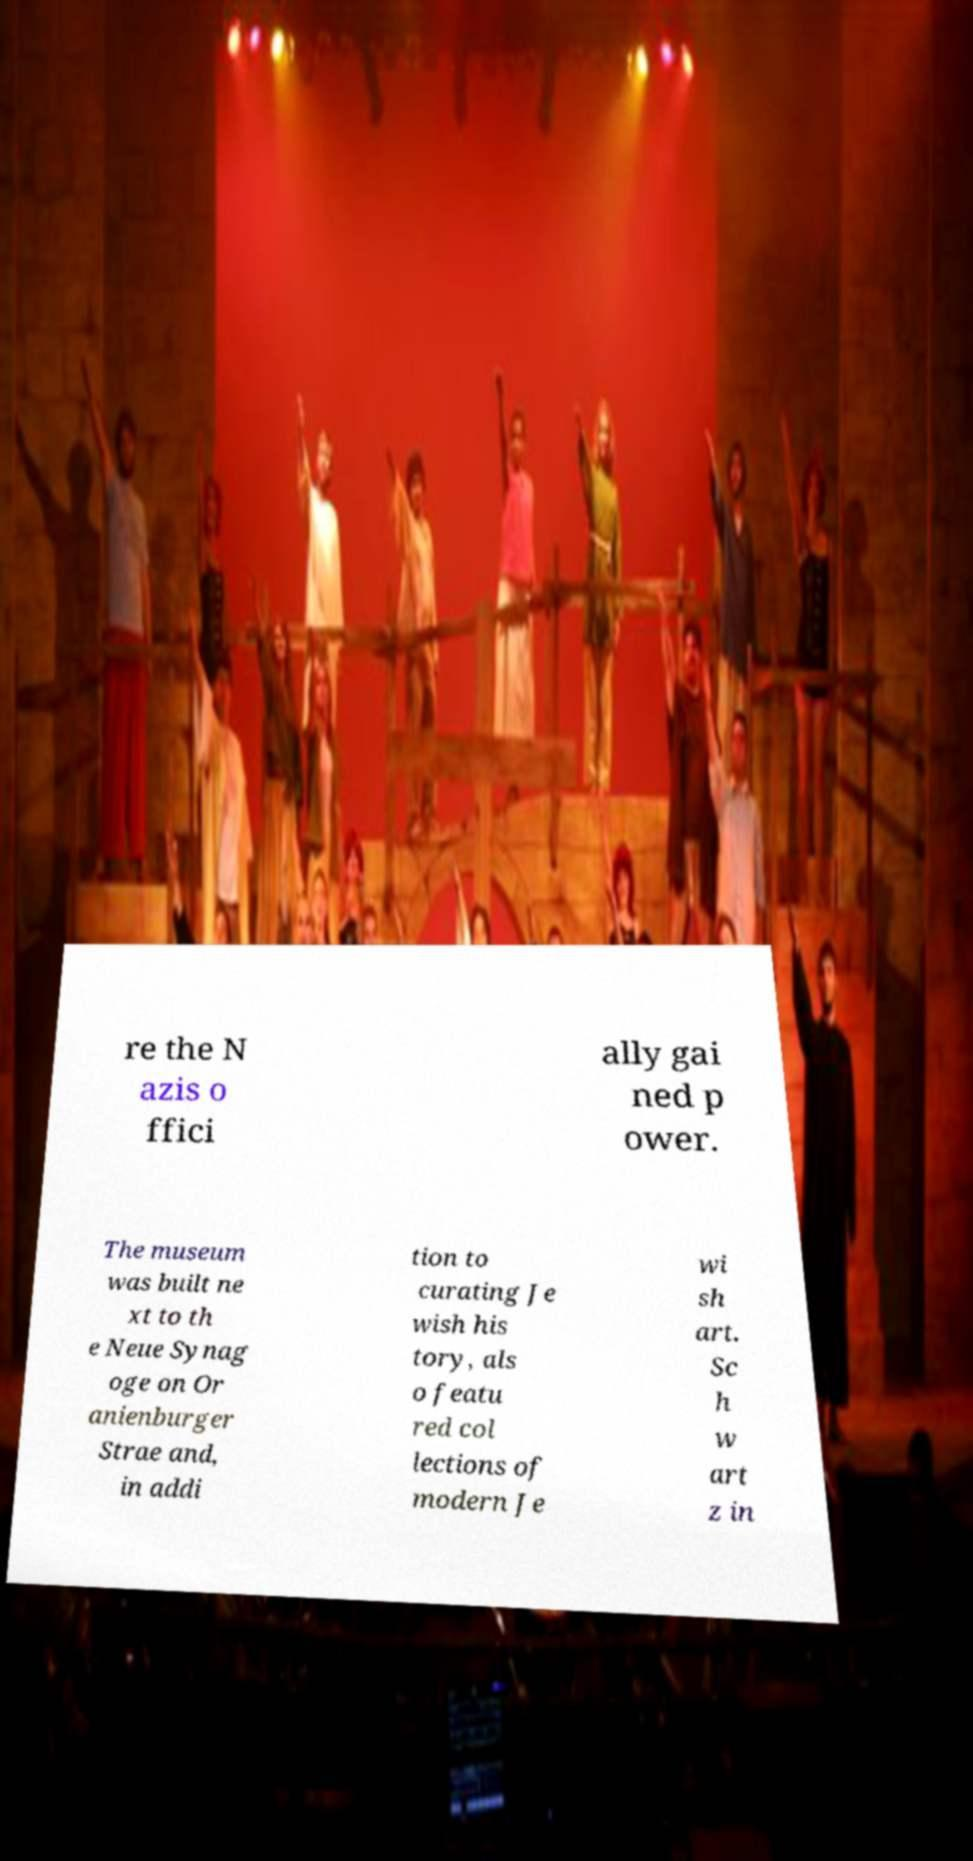What messages or text are displayed in this image? I need them in a readable, typed format. re the N azis o ffici ally gai ned p ower. The museum was built ne xt to th e Neue Synag oge on Or anienburger Strae and, in addi tion to curating Je wish his tory, als o featu red col lections of modern Je wi sh art. Sc h w art z in 